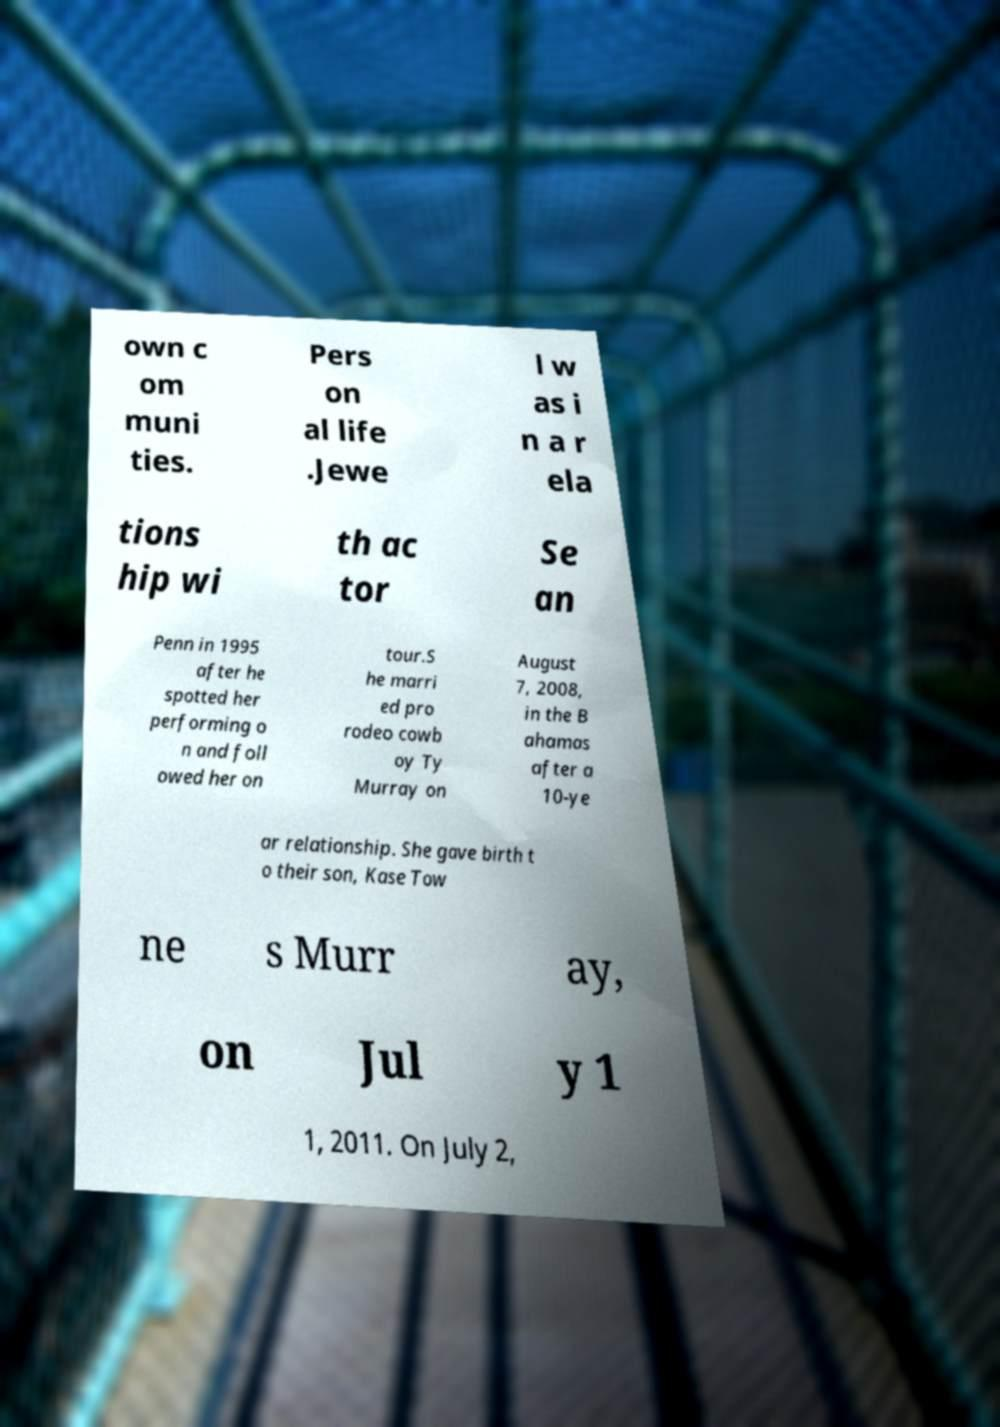For documentation purposes, I need the text within this image transcribed. Could you provide that? own c om muni ties. Pers on al life .Jewe l w as i n a r ela tions hip wi th ac tor Se an Penn in 1995 after he spotted her performing o n and foll owed her on tour.S he marri ed pro rodeo cowb oy Ty Murray on August 7, 2008, in the B ahamas after a 10-ye ar relationship. She gave birth t o their son, Kase Tow ne s Murr ay, on Jul y 1 1, 2011. On July 2, 